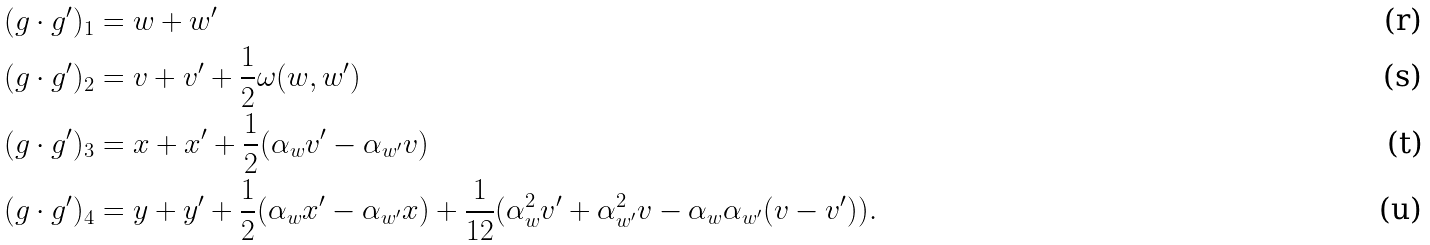Convert formula to latex. <formula><loc_0><loc_0><loc_500><loc_500>( g \cdot g ^ { \prime } ) _ { 1 } & = w + w ^ { \prime } \\ ( g \cdot g ^ { \prime } ) _ { 2 } & = v + v ^ { \prime } + \frac { 1 } { 2 } \omega ( w , w ^ { \prime } ) \\ ( g \cdot g ^ { \prime } ) _ { 3 } & = x + x ^ { \prime } + \frac { 1 } { 2 } ( \alpha _ { w } v ^ { \prime } - \alpha _ { w ^ { \prime } } v ) \\ ( g \cdot g ^ { \prime } ) _ { 4 } & = y + y ^ { \prime } + \frac { 1 } { 2 } ( \alpha _ { w } x ^ { \prime } - \alpha _ { w ^ { \prime } } x ) + \frac { 1 } { 1 2 } ( \alpha _ { w } ^ { 2 } v ^ { \prime } + \alpha _ { w ^ { \prime } } ^ { 2 } v - \alpha _ { w } \alpha _ { w ^ { \prime } } ( v - v ^ { \prime } ) ) .</formula> 